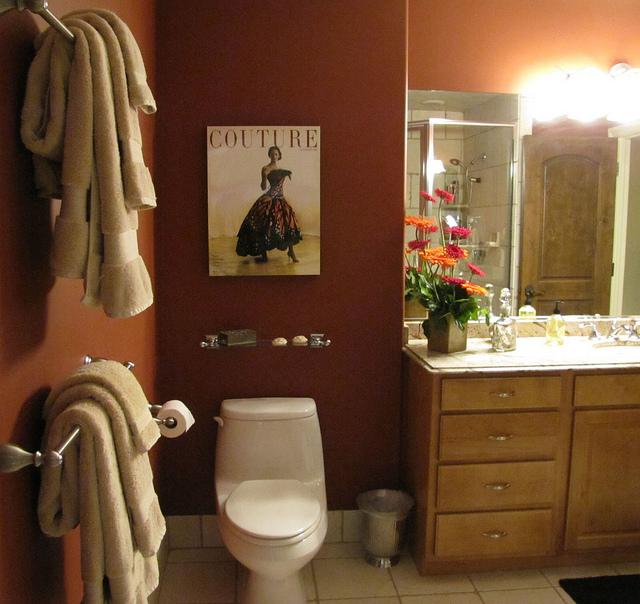Is the toilet lid up?
Concise answer only. No. What color is the towel?
Concise answer only. White. What is the word on the top of the poster above the toilet?
Be succinct. Couture. What is the person suppose to do here?
Concise answer only. Pee. Are there fresh flowers?
Give a very brief answer. Yes. What is in the vase on the counter?
Be succinct. Flowers. What shape is the mirror on the wall?
Answer briefly. Square. Is this a store?
Concise answer only. No. Was this picture taken in an office?
Quick response, please. No. 